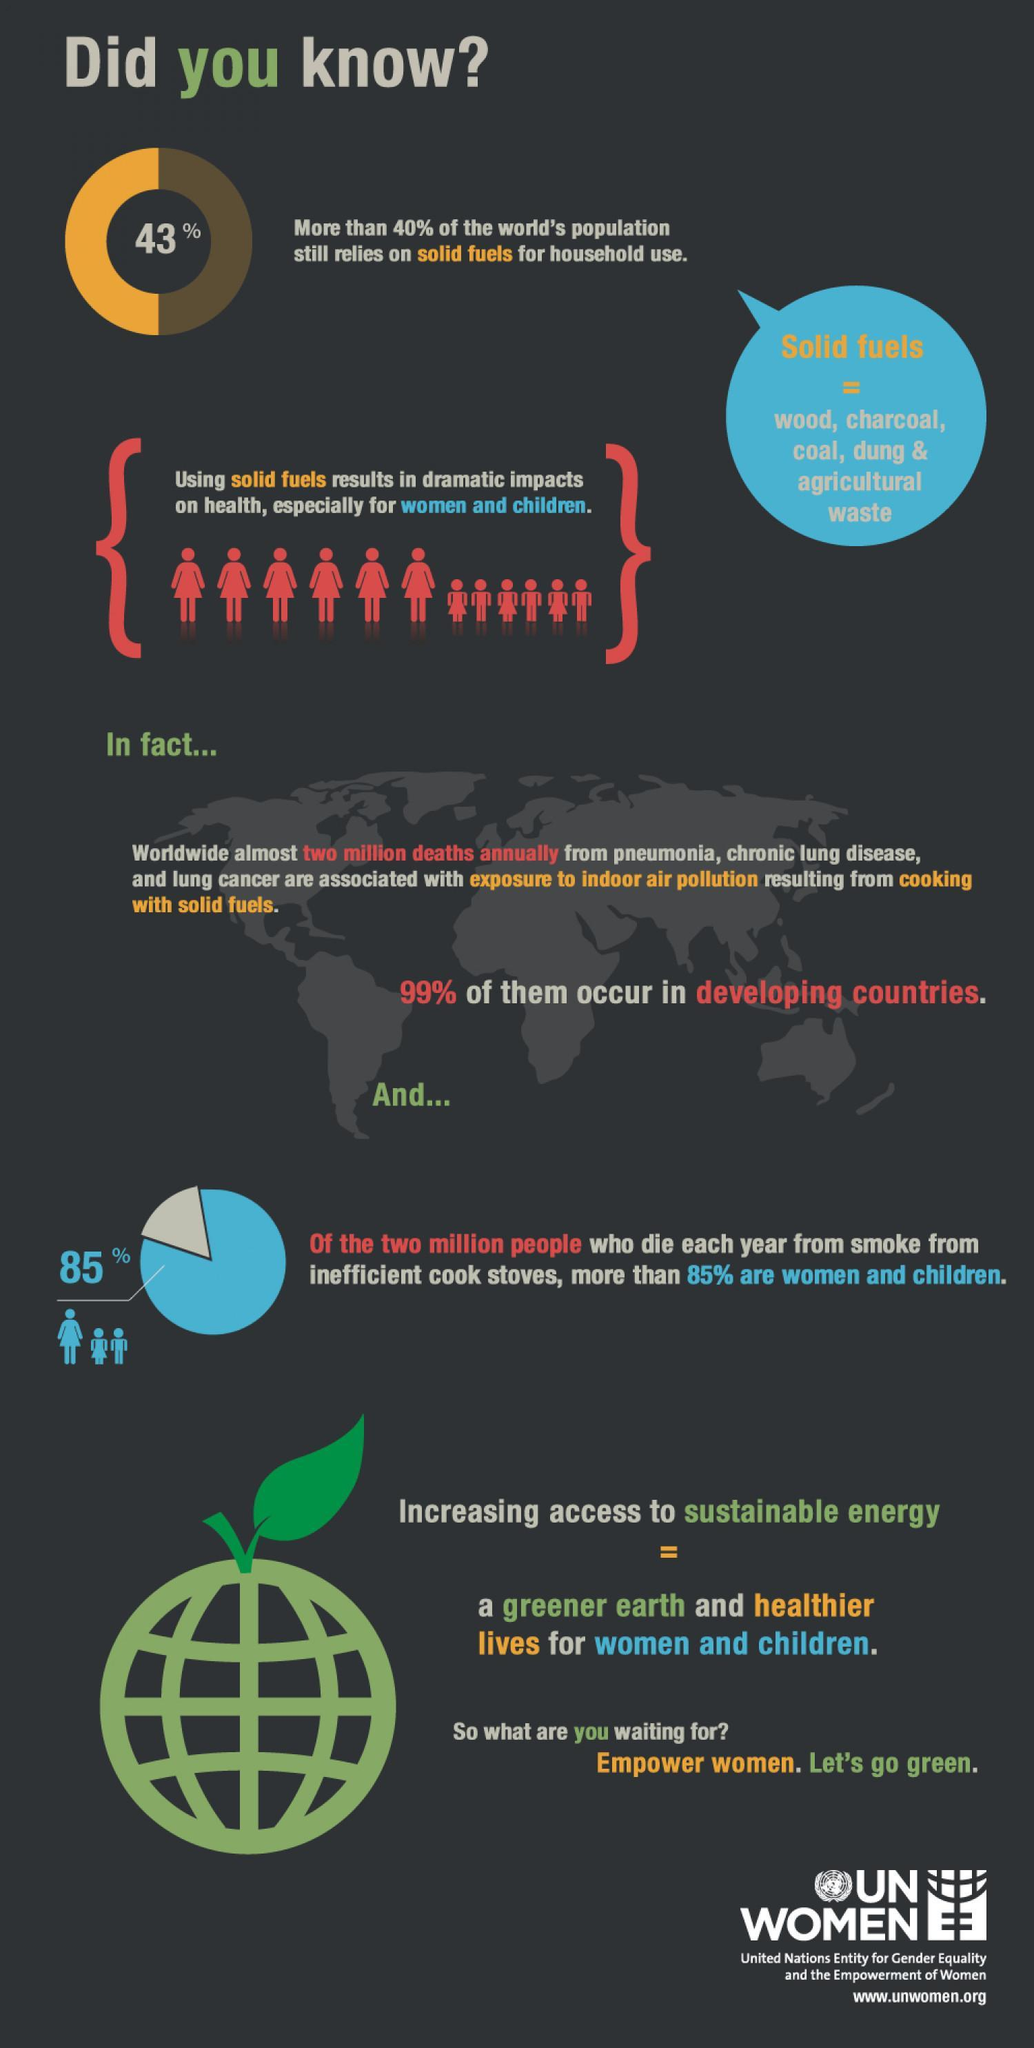What percentage of men are causalities to cooking smoke?
Answer the question with a short phrase. 15% 